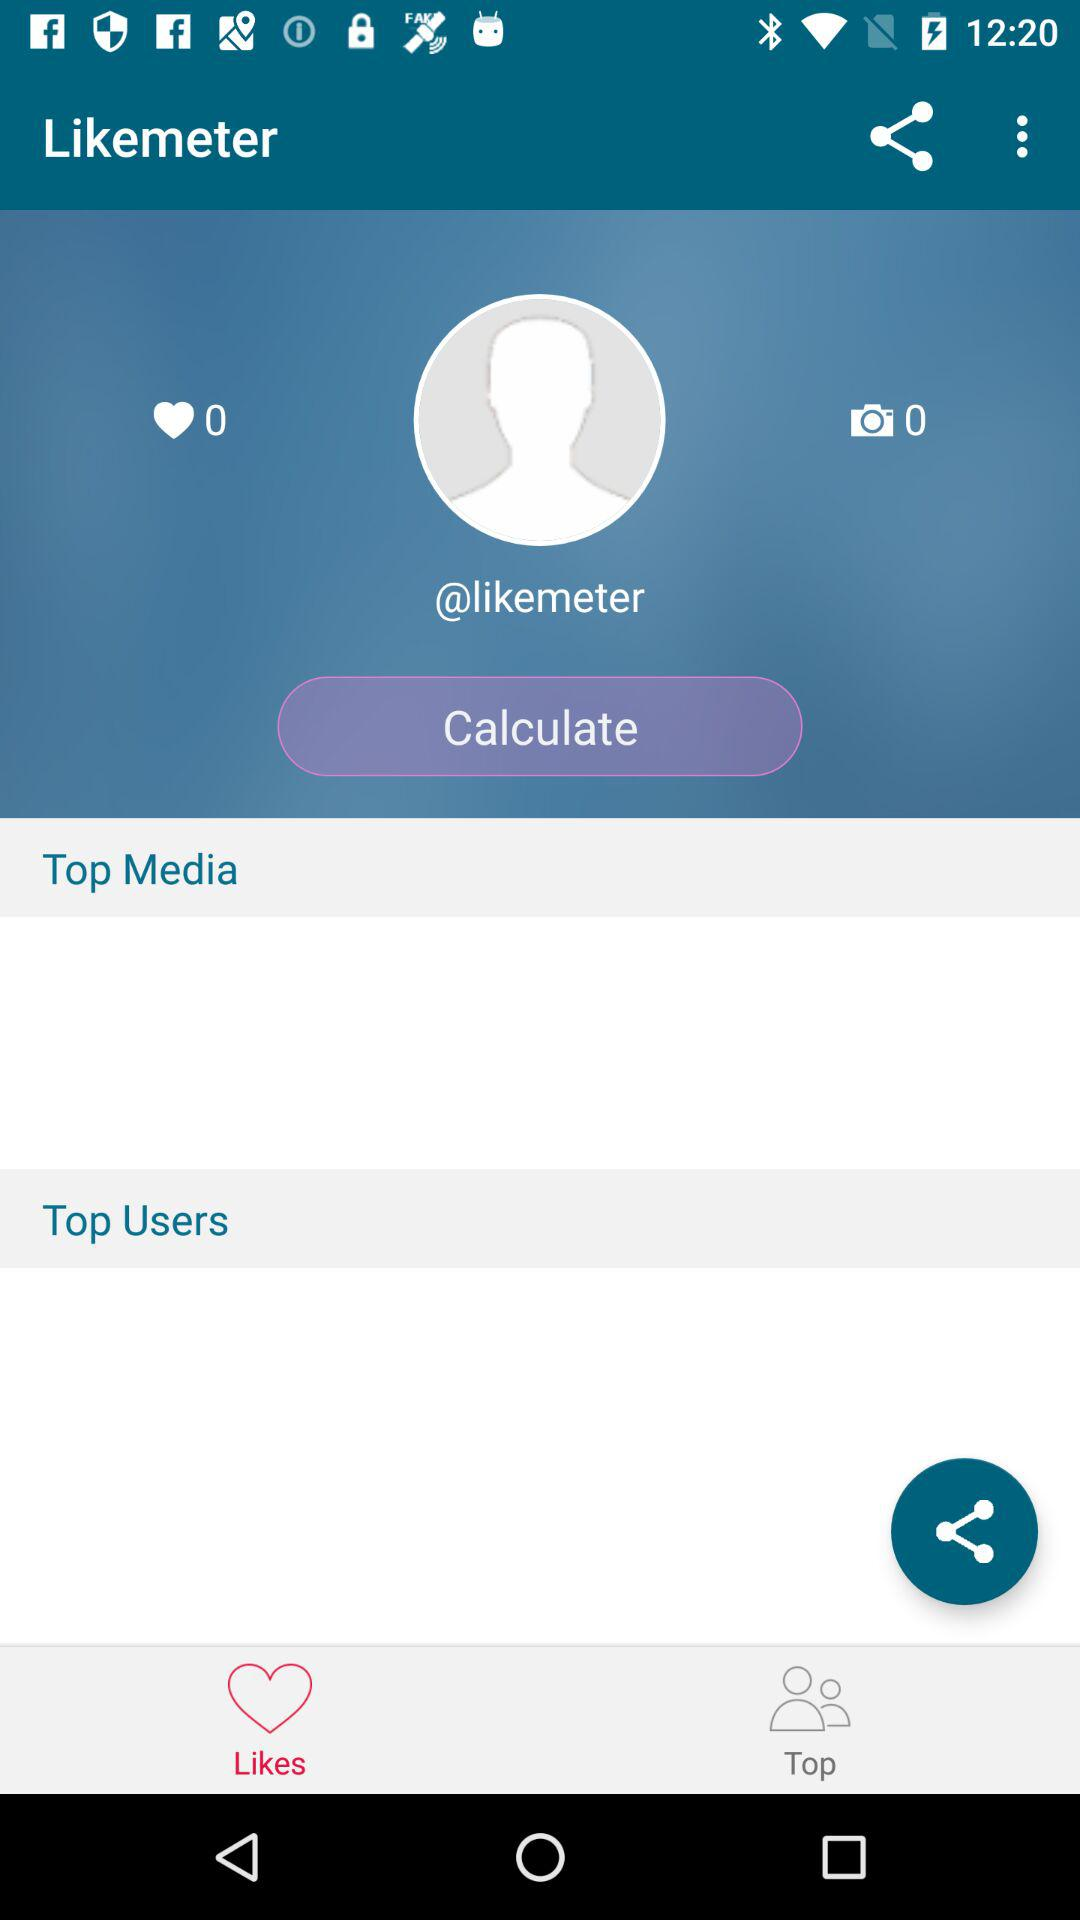Which tab is selected? The selected tab is "Likes". 